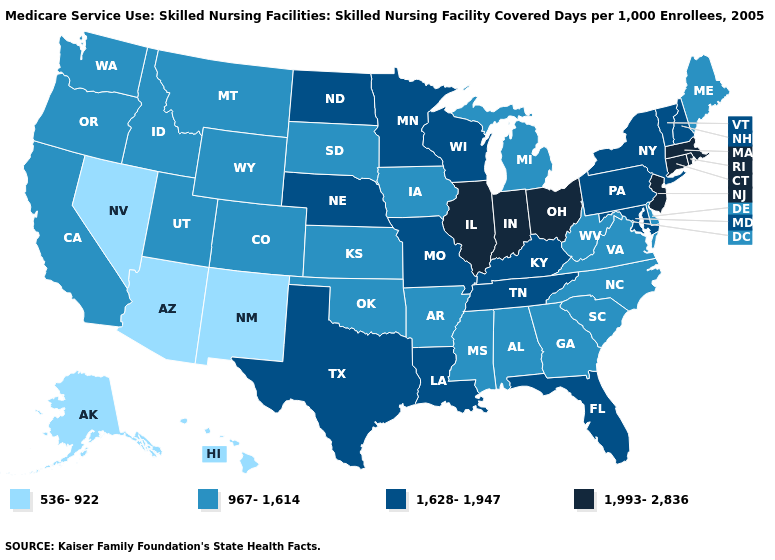What is the value of Hawaii?
Answer briefly. 536-922. Among the states that border West Virginia , does Virginia have the lowest value?
Concise answer only. Yes. What is the value of Alabama?
Be succinct. 967-1,614. What is the highest value in states that border Idaho?
Concise answer only. 967-1,614. Does South Dakota have a higher value than Arizona?
Answer briefly. Yes. What is the highest value in states that border New Mexico?
Be succinct. 1,628-1,947. What is the value of Florida?
Concise answer only. 1,628-1,947. Name the states that have a value in the range 1,628-1,947?
Quick response, please. Florida, Kentucky, Louisiana, Maryland, Minnesota, Missouri, Nebraska, New Hampshire, New York, North Dakota, Pennsylvania, Tennessee, Texas, Vermont, Wisconsin. Among the states that border Utah , does Wyoming have the lowest value?
Answer briefly. No. Which states have the lowest value in the Northeast?
Answer briefly. Maine. What is the value of New York?
Concise answer only. 1,628-1,947. Does Oregon have the same value as Kentucky?
Concise answer only. No. Does Connecticut have the lowest value in the Northeast?
Be succinct. No. What is the value of North Dakota?
Keep it brief. 1,628-1,947. Name the states that have a value in the range 967-1,614?
Short answer required. Alabama, Arkansas, California, Colorado, Delaware, Georgia, Idaho, Iowa, Kansas, Maine, Michigan, Mississippi, Montana, North Carolina, Oklahoma, Oregon, South Carolina, South Dakota, Utah, Virginia, Washington, West Virginia, Wyoming. 